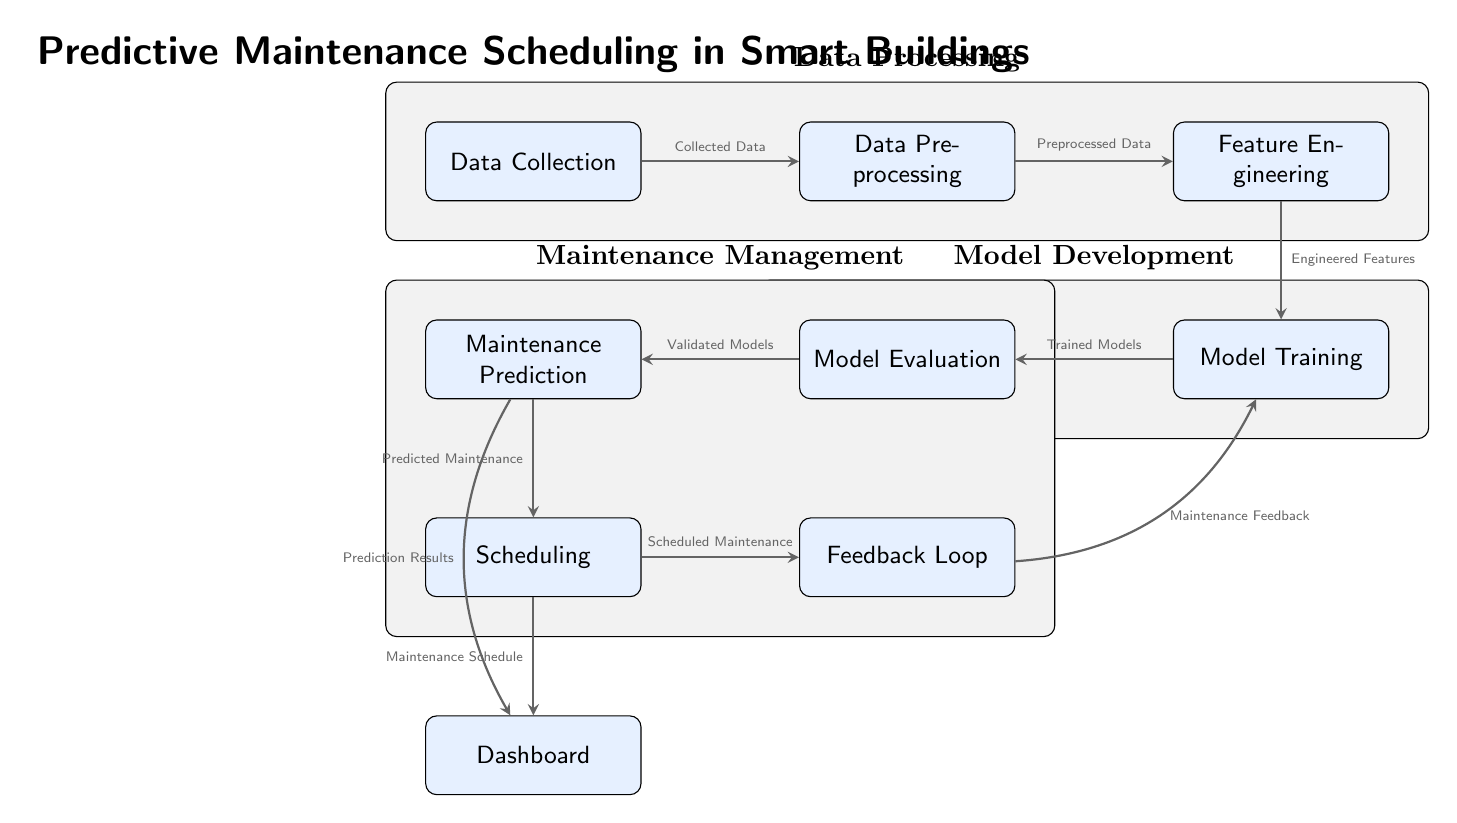What is the first step in the diagram? The first step in the diagram is 'Data Collection,' which is represented as the leftmost node in the diagram.
Answer: Data Collection How many layers are displayed in the diagram? There are three layers in the diagram: Data Processing, Model Development, and Maintenance Management, indicated by the shaded areas.
Answer: Three What does the 'Feedback Loop' contribute to the 'Model Training'? The 'Feedback Loop' supplies 'Maintenance Feedback,' which is essential for updating and improving the models in 'Model Training.'
Answer: Maintenance Feedback Which node follows 'Model Evaluation'? 'Maintenance Prediction' follows 'Model Evaluation,' as indicated by the arrow flow connecting them sequentially in the diagram.
Answer: Maintenance Prediction What is the relationship between 'Scheduling' and 'Dashboard'? 'Scheduling' provides the 'Maintenance Schedule' to the 'Dashboard,' establishing a direct connection between them in the diagram.
Answer: Maintenance Schedule What type of data is produced after 'Model Training'? 'Trained Models' are produced after 'Model Training', which is a crucial outcome before proceeding with 'Model Evaluation.'
Answer: Trained Models What connects 'Maintenance Prediction' to 'Scheduling'? 'Predicted Maintenance' is the output from 'Maintenance Prediction' that leads directly into the 'Scheduling' process.
Answer: Predicted Maintenance Which step in the process validates the models? The 'Model Evaluation' step is responsible for validating the models after they've been trained.
Answer: Model Evaluation What does 'Feature Engineering' output? 'Feature Engineering' outputs 'Engineered Features,' which are used for the next step of 'Model Training.'
Answer: Engineered Features 